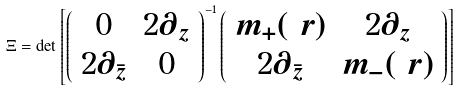Convert formula to latex. <formula><loc_0><loc_0><loc_500><loc_500>\Xi = \det \left [ \left ( \begin{array} { c c } 0 & 2 \partial _ { z } \\ 2 \partial _ { \bar { z } } & 0 \end{array} \right ) ^ { - 1 } \left ( \begin{array} { c c } m _ { + } ( \ r ) & 2 \partial _ { z } \\ 2 \partial _ { \bar { z } } & m _ { - } ( \ r ) \end{array} \right ) \right ]</formula> 